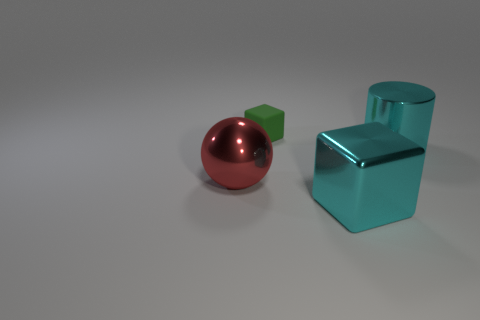Add 2 big blue matte cubes. How many objects exist? 6 Subtract all green blocks. How many blocks are left? 1 Subtract all spheres. How many objects are left? 3 Subtract all gray cylinders. Subtract all blue cubes. How many cylinders are left? 1 Subtract all brown cylinders. How many cyan blocks are left? 1 Subtract all small brown rubber cylinders. Subtract all cyan shiny blocks. How many objects are left? 3 Add 3 metal cylinders. How many metal cylinders are left? 4 Add 3 large red rubber objects. How many large red rubber objects exist? 3 Subtract 1 cyan blocks. How many objects are left? 3 